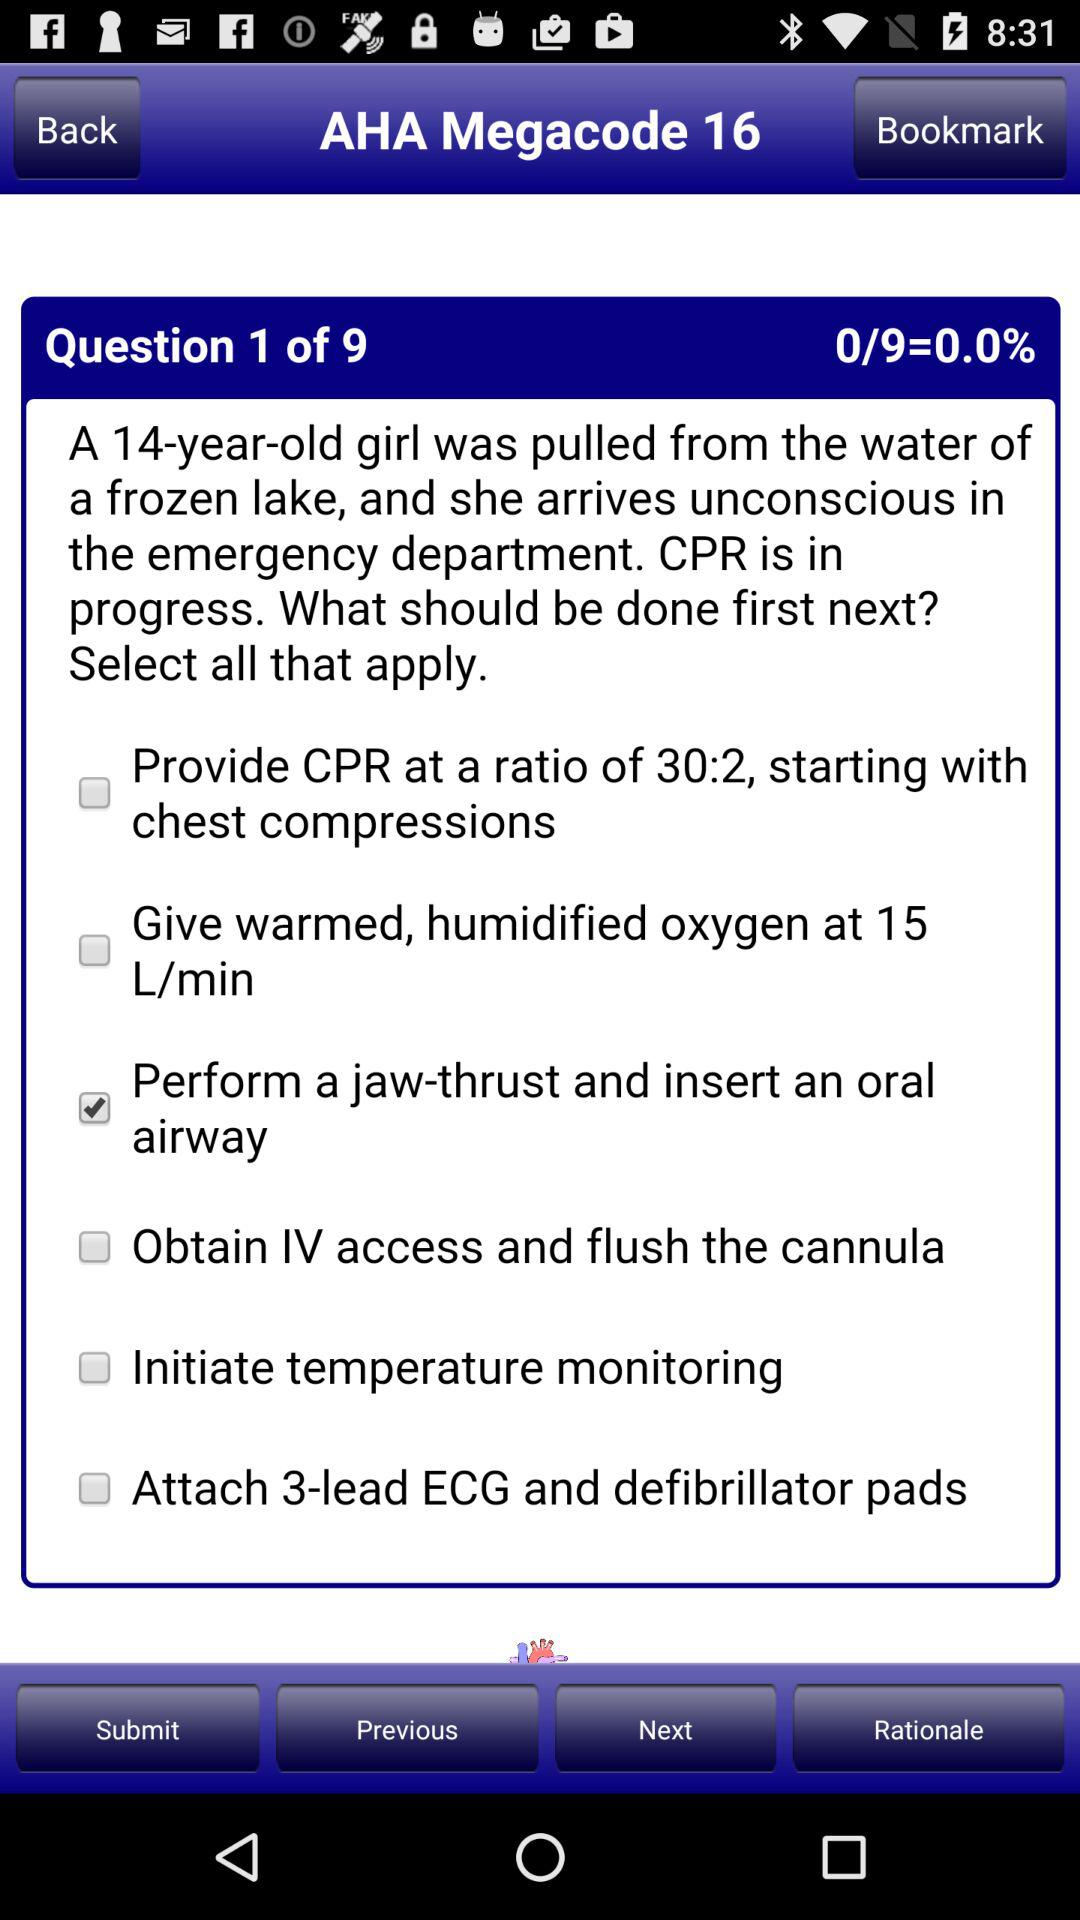How many questions in total are there? There are 9 questions in total. 